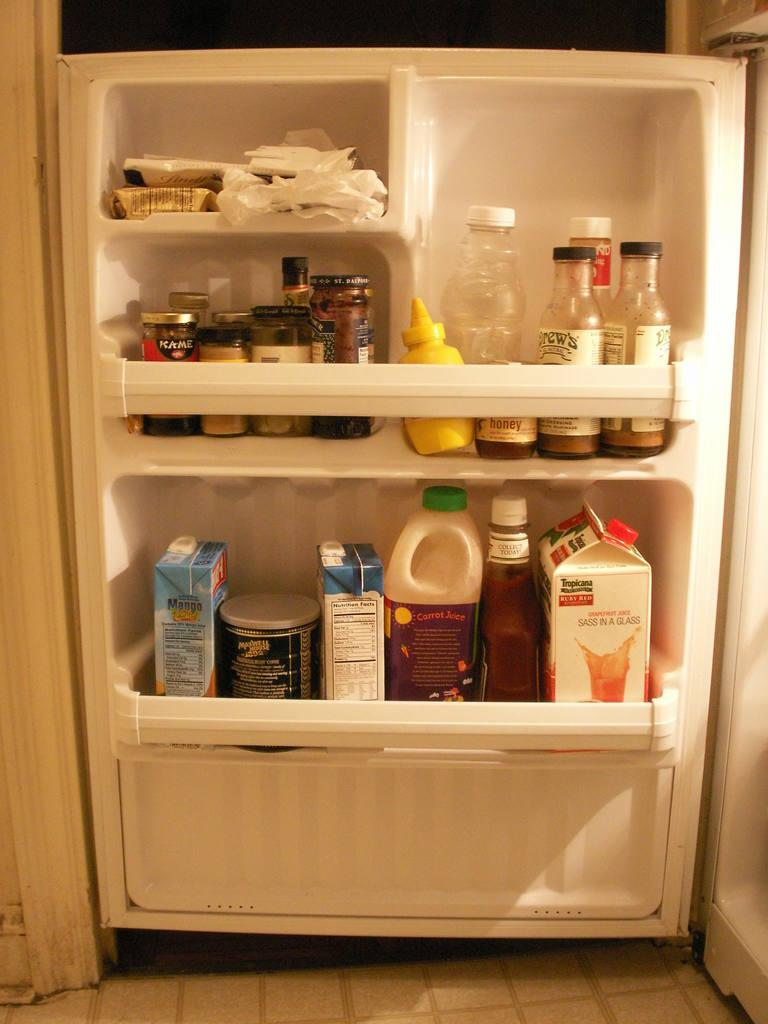<image>
Offer a succinct explanation of the picture presented. A fridge door is open and full of food including a jar that says Honey. 